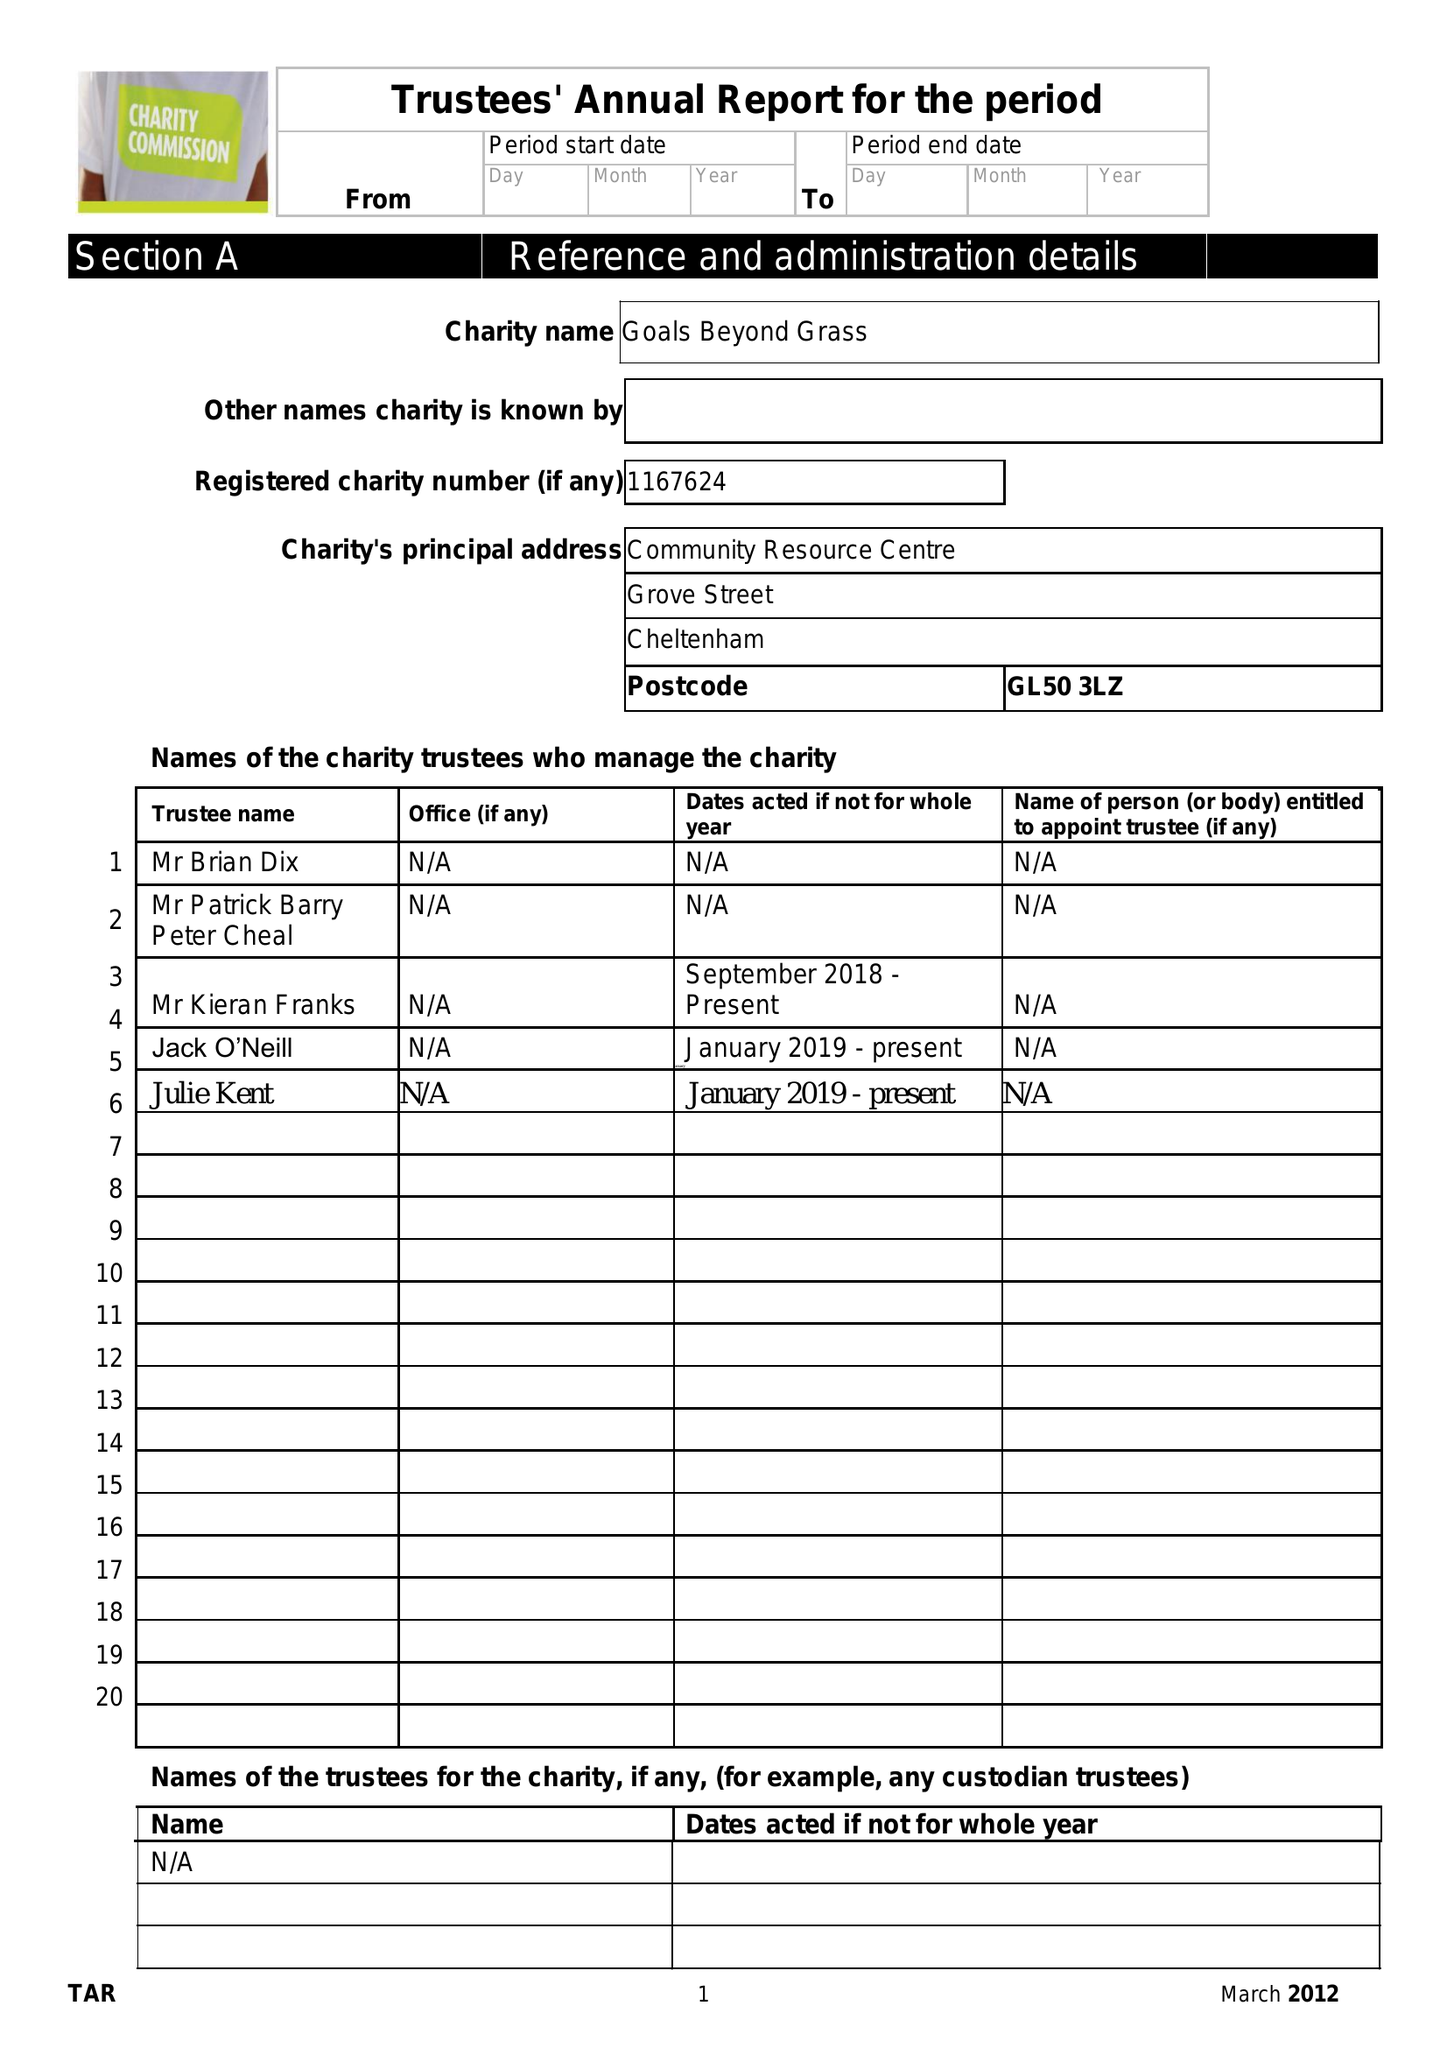What is the value for the address__street_line?
Answer the question using a single word or phrase. 40B LONDON ROAD 